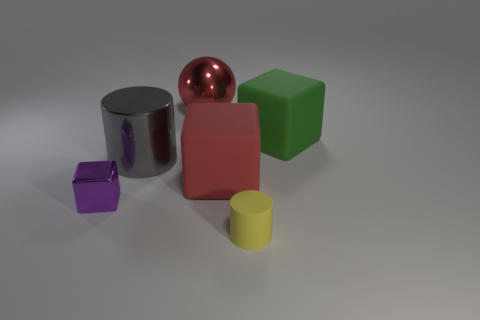How many objects are either red matte things or tiny brown metallic things?
Your answer should be compact. 1. There is a green rubber thing; what number of large green matte things are behind it?
Provide a succinct answer. 0. Is the color of the tiny matte cylinder the same as the small block?
Provide a short and direct response. No. There is a big red thing that is made of the same material as the green cube; what shape is it?
Give a very brief answer. Cube. There is a big thing that is on the right side of the yellow rubber cylinder; is it the same shape as the small yellow matte thing?
Keep it short and to the point. No. What number of red objects are either spheres or cylinders?
Provide a succinct answer. 1. Are there an equal number of tiny purple things that are on the right side of the red matte block and big things left of the large metal cylinder?
Offer a very short reply. Yes. What is the color of the big rubber thing that is in front of the big matte cube to the right of the red thing that is on the right side of the large red metallic ball?
Make the answer very short. Red. Is there any other thing that has the same color as the big cylinder?
Offer a very short reply. No. What is the shape of the rubber object that is the same color as the large sphere?
Ensure brevity in your answer.  Cube. 